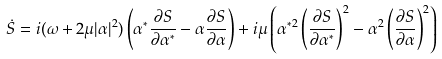<formula> <loc_0><loc_0><loc_500><loc_500>\dot { S } = i ( \omega + 2 \mu | \alpha | ^ { 2 } ) \left ( \alpha ^ { * } \frac { \partial S } { \partial \alpha ^ { * } } - \alpha \frac { \partial S } { \partial \alpha } \right ) + i \mu \left ( \alpha ^ { * 2 } \left ( \frac { \partial S } { \partial \alpha ^ { * } } \right ) ^ { 2 } - \alpha ^ { 2 } \left ( \frac { \partial S } { \partial \alpha } \right ) ^ { 2 } \right )</formula> 